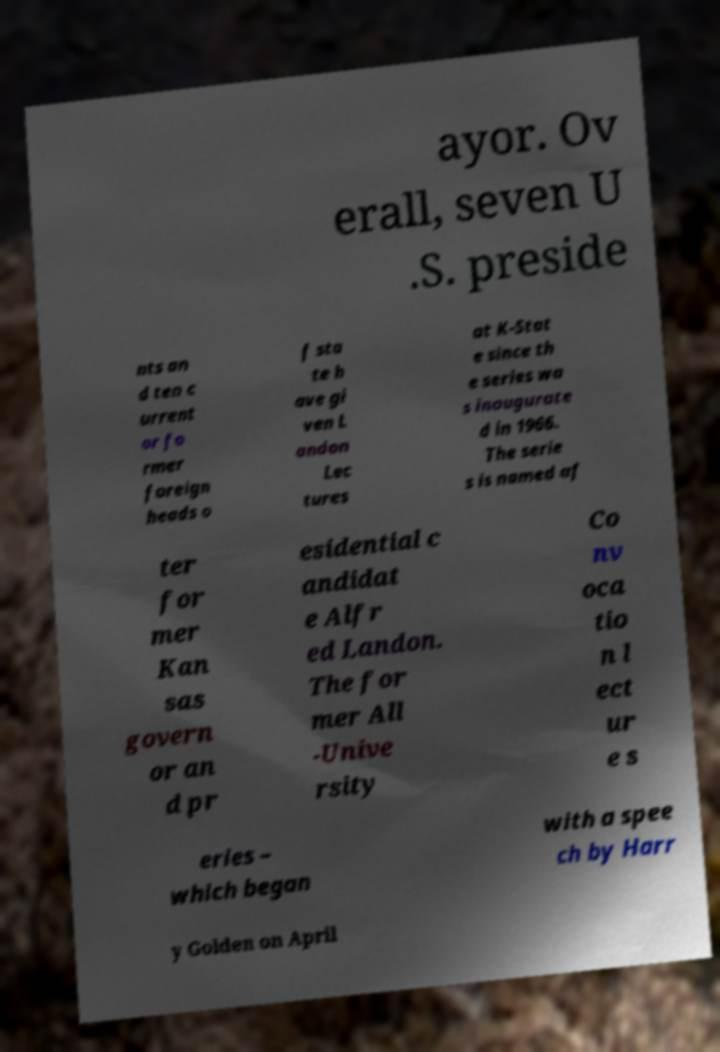Could you assist in decoding the text presented in this image and type it out clearly? ayor. Ov erall, seven U .S. preside nts an d ten c urrent or fo rmer foreign heads o f sta te h ave gi ven L andon Lec tures at K-Stat e since th e series wa s inaugurate d in 1966. The serie s is named af ter for mer Kan sas govern or an d pr esidential c andidat e Alfr ed Landon. The for mer All -Unive rsity Co nv oca tio n l ect ur e s eries – which began with a spee ch by Harr y Golden on April 